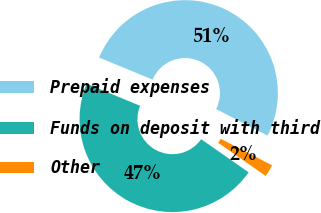Convert chart to OTSL. <chart><loc_0><loc_0><loc_500><loc_500><pie_chart><fcel>Prepaid expenses<fcel>Funds on deposit with third<fcel>Other<nl><fcel>51.32%<fcel>46.55%<fcel>2.13%<nl></chart> 